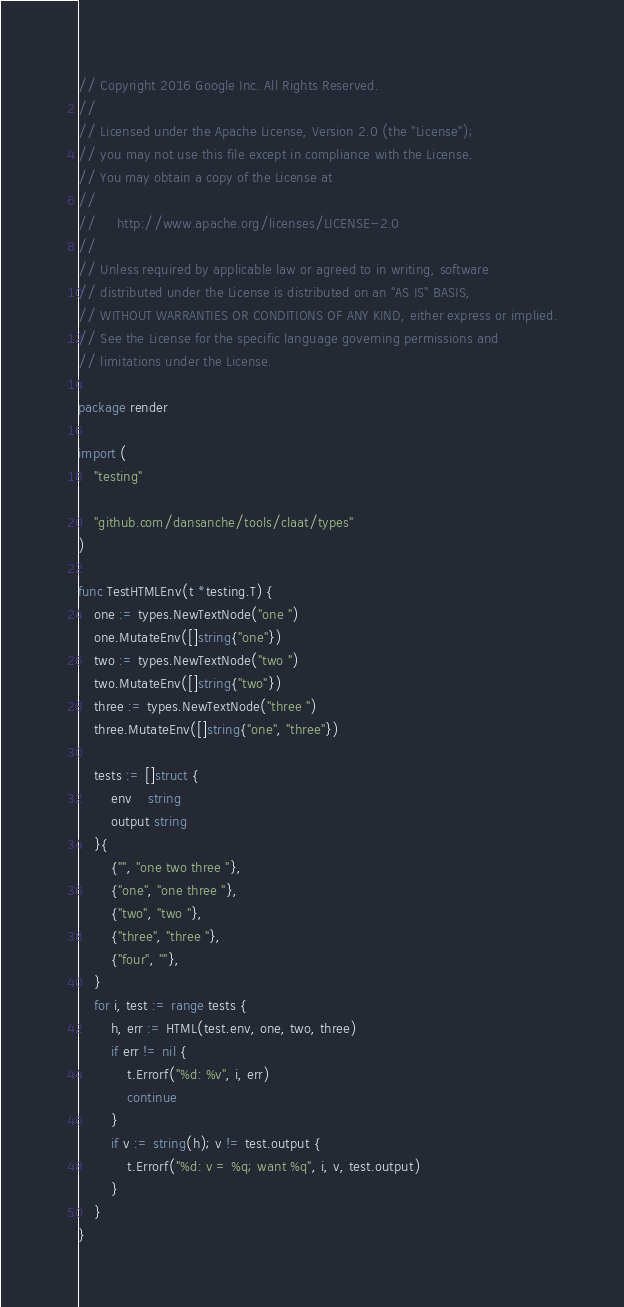<code> <loc_0><loc_0><loc_500><loc_500><_Go_>// Copyright 2016 Google Inc. All Rights Reserved.
//
// Licensed under the Apache License, Version 2.0 (the "License");
// you may not use this file except in compliance with the License.
// You may obtain a copy of the License at
//
//     http://www.apache.org/licenses/LICENSE-2.0
//
// Unless required by applicable law or agreed to in writing, software
// distributed under the License is distributed on an "AS IS" BASIS,
// WITHOUT WARRANTIES OR CONDITIONS OF ANY KIND, either express or implied.
// See the License for the specific language governing permissions and
// limitations under the License.

package render

import (
	"testing"

	"github.com/dansanche/tools/claat/types"
)

func TestHTMLEnv(t *testing.T) {
	one := types.NewTextNode("one ")
	one.MutateEnv([]string{"one"})
	two := types.NewTextNode("two ")
	two.MutateEnv([]string{"two"})
	three := types.NewTextNode("three ")
	three.MutateEnv([]string{"one", "three"})

	tests := []struct {
		env    string
		output string
	}{
		{"", "one two three "},
		{"one", "one three "},
		{"two", "two "},
		{"three", "three "},
		{"four", ""},
	}
	for i, test := range tests {
		h, err := HTML(test.env, one, two, three)
		if err != nil {
			t.Errorf("%d: %v", i, err)
			continue
		}
		if v := string(h); v != test.output {
			t.Errorf("%d: v = %q; want %q", i, v, test.output)
		}
	}
}
</code> 